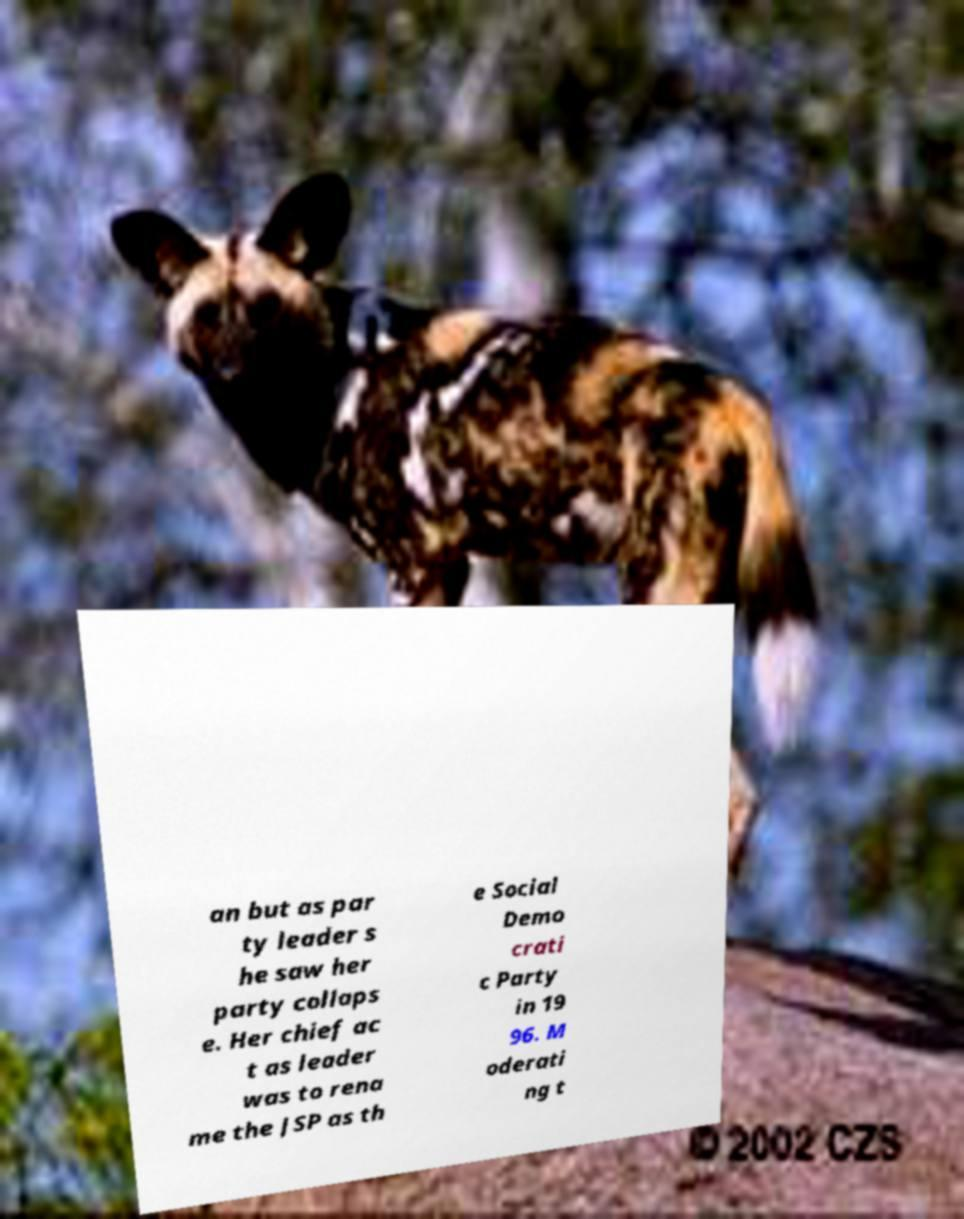There's text embedded in this image that I need extracted. Can you transcribe it verbatim? an but as par ty leader s he saw her party collaps e. Her chief ac t as leader was to rena me the JSP as th e Social Demo crati c Party in 19 96. M oderati ng t 